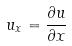Convert formula to latex. <formula><loc_0><loc_0><loc_500><loc_500>u _ { x } = \frac { \partial u } { \partial x }</formula> 